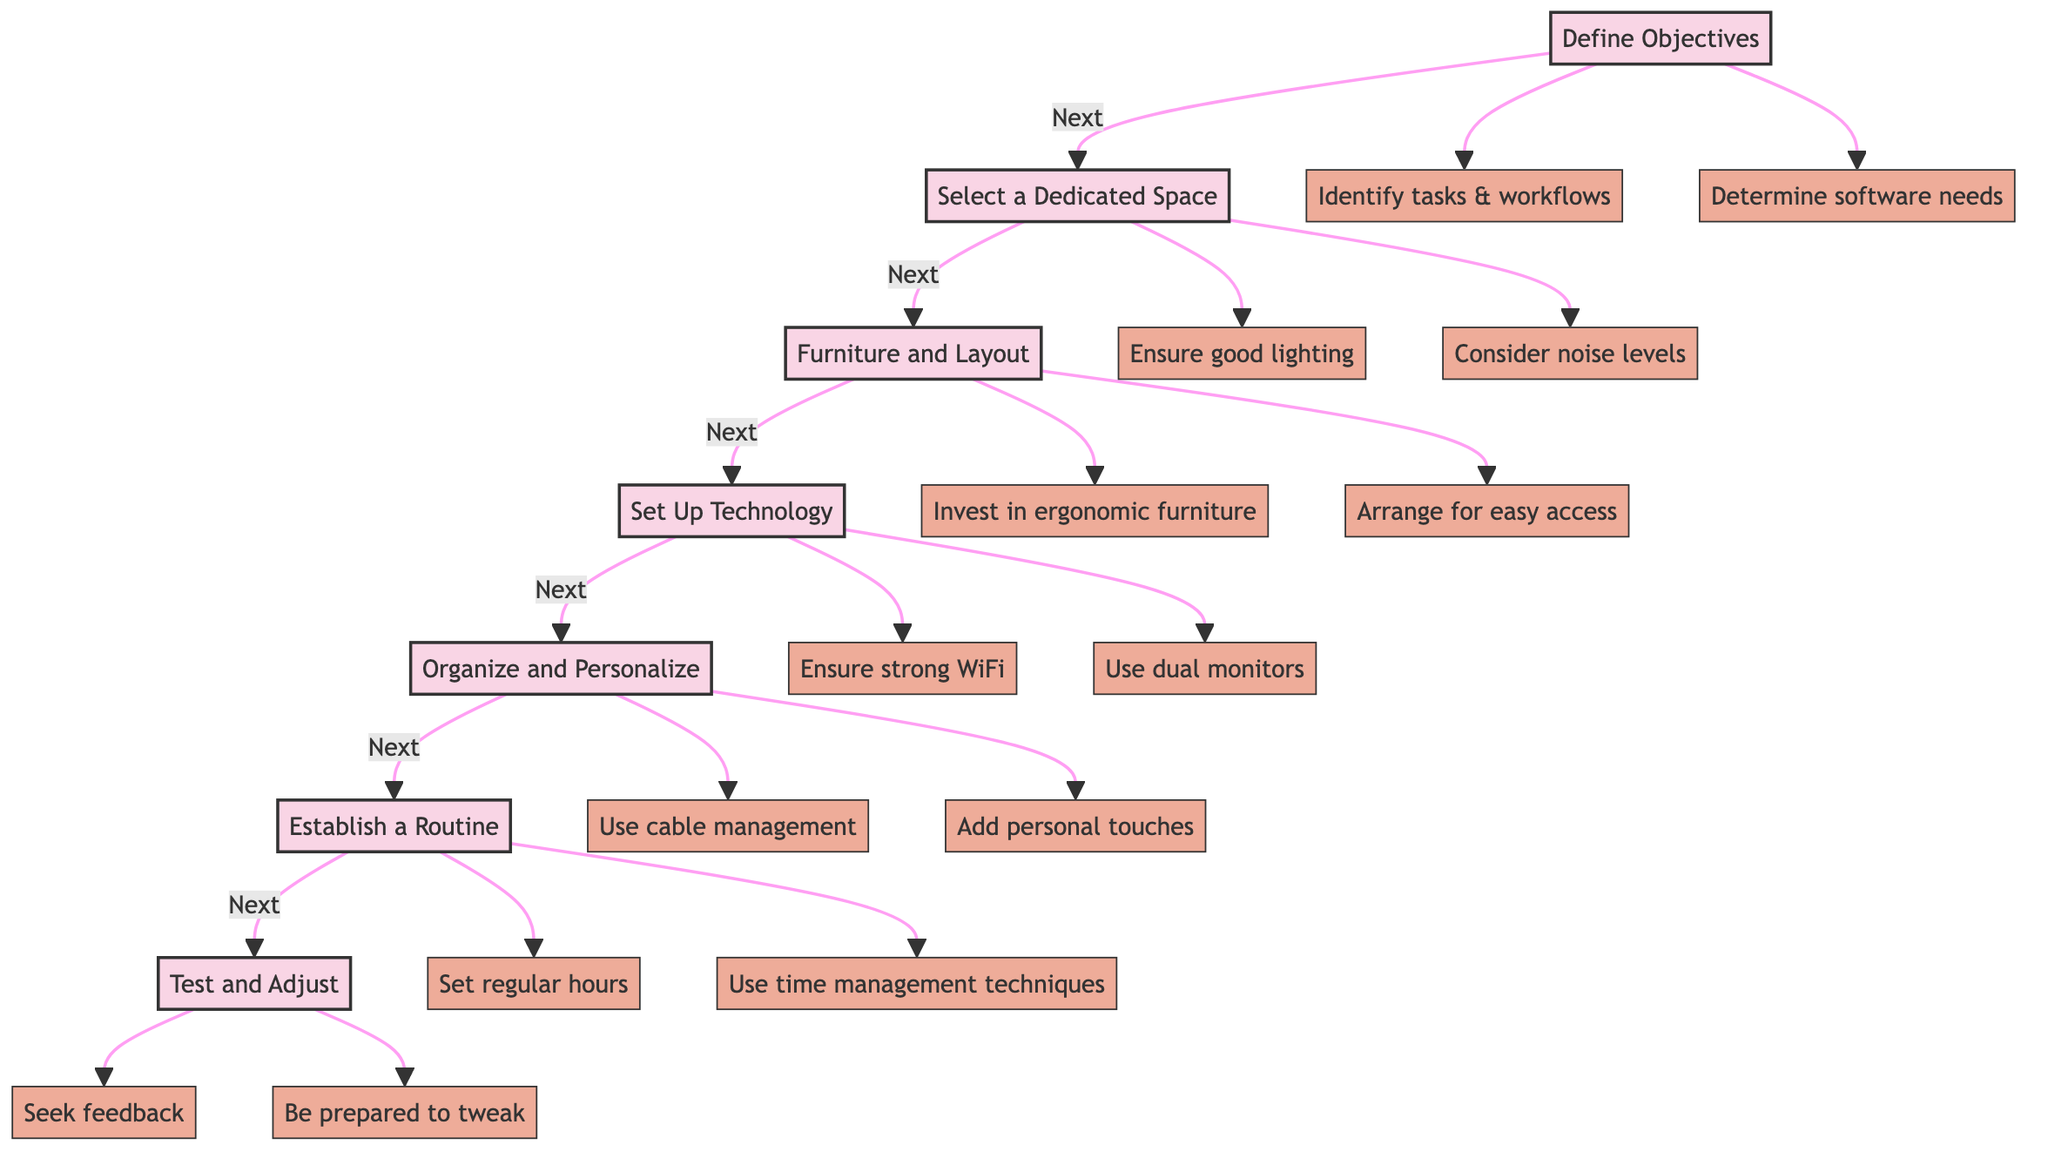What is the first step in the diagram? The first step listed in the diagram is "Define Objectives." This step initiates the workflow for setting up a home office.
Answer: Define Objectives How many tips are provided under the "Organize and Personalize" step? Under the "Organize and Personalize" step, there are two tips provided: "Use cable management tools to avoid clutter," and "Add personal touches like plants or artwork to create an inviting atmosphere."
Answer: 2 What comes after "Set Up Technology"? The step that comes after "Set Up Technology" is "Organize and Personalize." This is a direct sequential relationship within the flowchart indicating the next action to take after setting up the necessary technology.
Answer: Organize and Personalize Which step suggests investing in ergonomic furniture? The step that suggests investing in ergonomic furniture is "Furniture and Layout." This indicates that choosing the right furniture is a critical aspect of creating a productive home office.
Answer: Furniture and Layout What is the last step in the flowchart? The last step in the flowchart is "Test and Adjust." This final step emphasizes the importance of evaluating the setup and making improvements where necessary.
Answer: Test and Adjust How is the relationship between "Select a Dedicated Space" and ensuring good lighting described? "Select a Dedicated Space" has a relationship with ensuring good lighting indicated by the connection from "Select a Dedicated Space" to a specific tip: "Ensure good lighting." This demonstrates that lighting is an important factor when choosing a workspace.
Answer: Ensuring good lighting What two aspects are suggested to determine in the "Define Objectives" step? The two aspects suggested in the "Define Objectives" step are "Identify tasks & workflows" and "Determine software needs." These pertain to understanding work requirements and the tools necessary for productivity.
Answer: Identify tasks & workflows, Determine software needs What is indicated by the flowchart's step before "Establish a Routine"? The step indicated before "Establish a Routine" is "Organize and Personalize." This means setting up your workspace and making it conducive to personal comfort comes before establishing a daily work schedule.
Answer: Organize and Personalize 